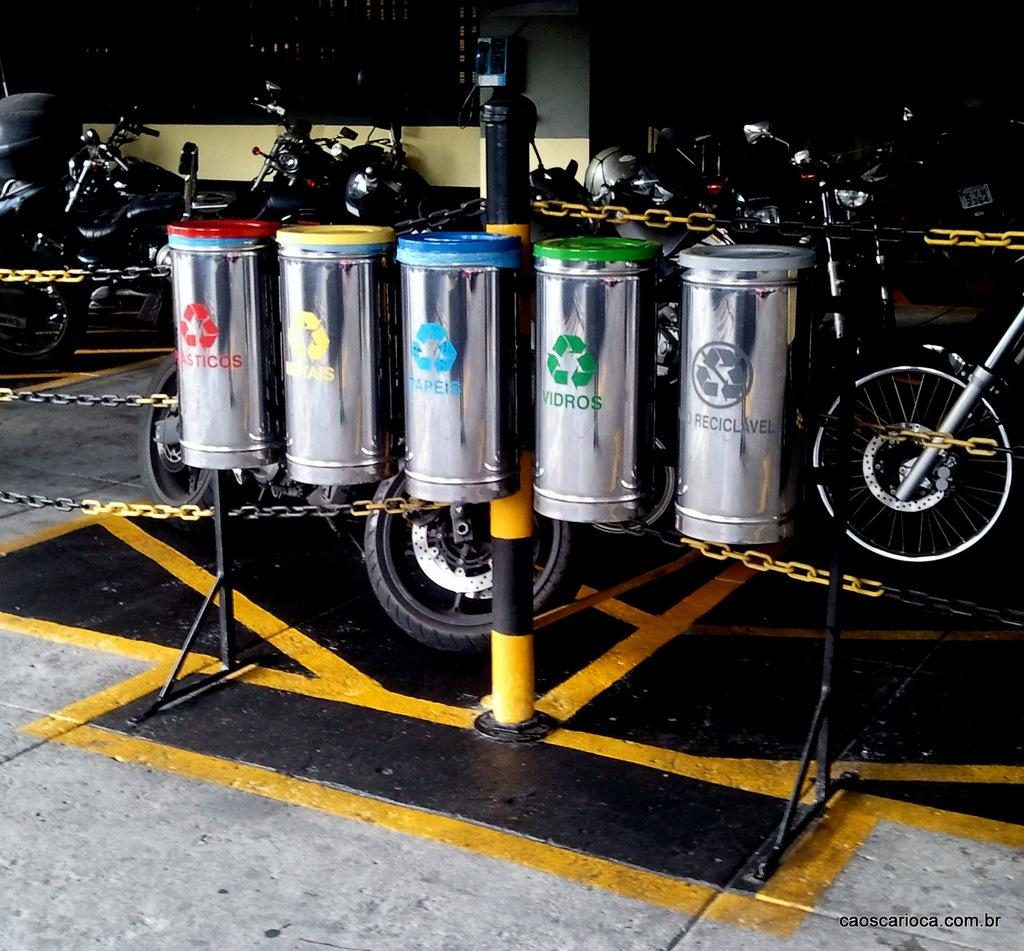What objects are present in the image? There are five steel boxes and chains from left to right in the image. What can be seen in the background of the image? There are bikes and a wall in the background of the image. How much money is the girl holding in the image? There is no girl present in the image, and therefore no money can be observed. 